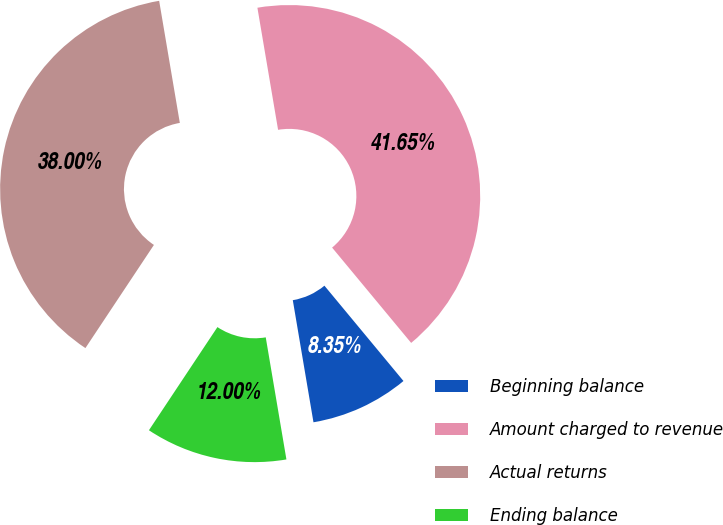Convert chart to OTSL. <chart><loc_0><loc_0><loc_500><loc_500><pie_chart><fcel>Beginning balance<fcel>Amount charged to revenue<fcel>Actual returns<fcel>Ending balance<nl><fcel>8.35%<fcel>41.65%<fcel>38.0%<fcel>12.0%<nl></chart> 